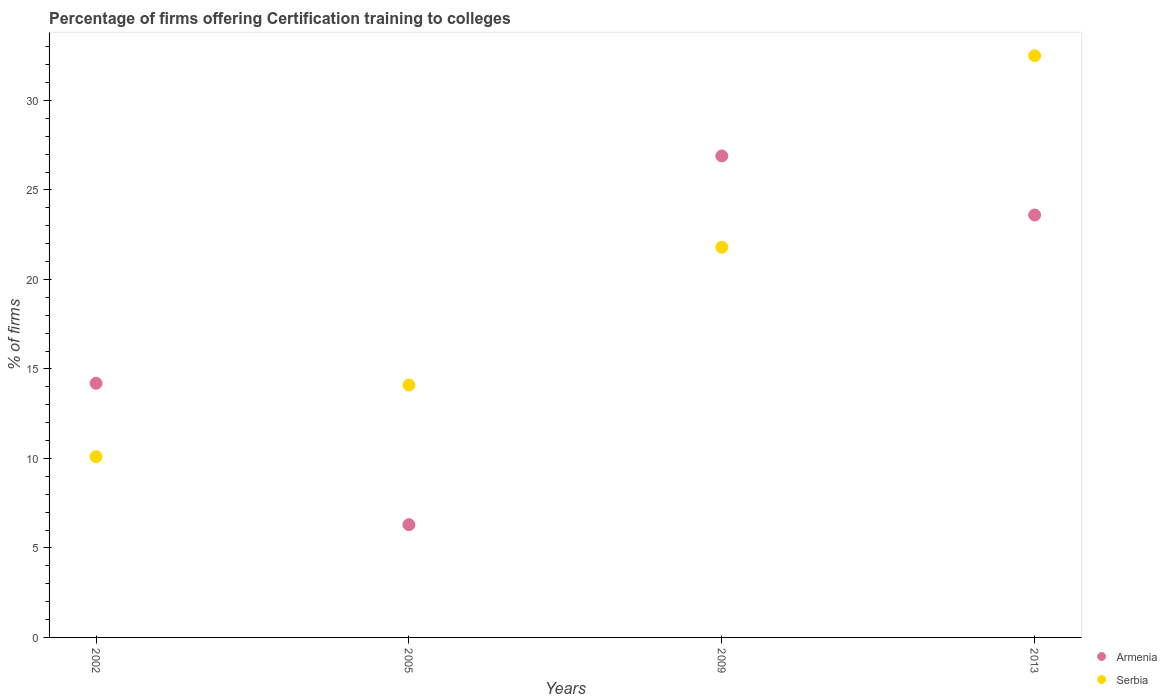How many different coloured dotlines are there?
Give a very brief answer. 2. Is the number of dotlines equal to the number of legend labels?
Your answer should be very brief. Yes. What is the percentage of firms offering certification training to colleges in Serbia in 2013?
Provide a short and direct response. 32.5. Across all years, what is the maximum percentage of firms offering certification training to colleges in Serbia?
Your answer should be very brief. 32.5. In which year was the percentage of firms offering certification training to colleges in Serbia maximum?
Give a very brief answer. 2013. What is the total percentage of firms offering certification training to colleges in Serbia in the graph?
Keep it short and to the point. 78.5. What is the difference between the percentage of firms offering certification training to colleges in Serbia in 2002 and that in 2009?
Make the answer very short. -11.7. What is the difference between the percentage of firms offering certification training to colleges in Armenia in 2002 and the percentage of firms offering certification training to colleges in Serbia in 2009?
Keep it short and to the point. -7.6. What is the average percentage of firms offering certification training to colleges in Armenia per year?
Your response must be concise. 17.75. In the year 2009, what is the difference between the percentage of firms offering certification training to colleges in Armenia and percentage of firms offering certification training to colleges in Serbia?
Ensure brevity in your answer.  5.1. In how many years, is the percentage of firms offering certification training to colleges in Armenia greater than 10 %?
Provide a succinct answer. 3. What is the ratio of the percentage of firms offering certification training to colleges in Serbia in 2002 to that in 2009?
Keep it short and to the point. 0.46. What is the difference between the highest and the second highest percentage of firms offering certification training to colleges in Armenia?
Provide a short and direct response. 3.3. What is the difference between the highest and the lowest percentage of firms offering certification training to colleges in Serbia?
Keep it short and to the point. 22.4. Is the sum of the percentage of firms offering certification training to colleges in Serbia in 2002 and 2013 greater than the maximum percentage of firms offering certification training to colleges in Armenia across all years?
Offer a very short reply. Yes. Does the percentage of firms offering certification training to colleges in Armenia monotonically increase over the years?
Give a very brief answer. No. Is the percentage of firms offering certification training to colleges in Armenia strictly less than the percentage of firms offering certification training to colleges in Serbia over the years?
Provide a short and direct response. No. How many dotlines are there?
Offer a terse response. 2. Are the values on the major ticks of Y-axis written in scientific E-notation?
Offer a terse response. No. Does the graph contain any zero values?
Offer a terse response. No. Does the graph contain grids?
Offer a very short reply. No. Where does the legend appear in the graph?
Provide a succinct answer. Bottom right. How many legend labels are there?
Your answer should be very brief. 2. How are the legend labels stacked?
Your response must be concise. Vertical. What is the title of the graph?
Ensure brevity in your answer.  Percentage of firms offering Certification training to colleges. What is the label or title of the Y-axis?
Your answer should be compact. % of firms. What is the % of firms of Armenia in 2002?
Make the answer very short. 14.2. What is the % of firms of Armenia in 2009?
Your answer should be very brief. 26.9. What is the % of firms in Serbia in 2009?
Ensure brevity in your answer.  21.8. What is the % of firms of Armenia in 2013?
Offer a very short reply. 23.6. What is the % of firms in Serbia in 2013?
Ensure brevity in your answer.  32.5. Across all years, what is the maximum % of firms in Armenia?
Ensure brevity in your answer.  26.9. Across all years, what is the maximum % of firms in Serbia?
Your answer should be very brief. 32.5. Across all years, what is the minimum % of firms in Serbia?
Offer a terse response. 10.1. What is the total % of firms in Armenia in the graph?
Offer a very short reply. 71. What is the total % of firms of Serbia in the graph?
Offer a terse response. 78.5. What is the difference between the % of firms of Serbia in 2002 and that in 2005?
Keep it short and to the point. -4. What is the difference between the % of firms of Serbia in 2002 and that in 2009?
Provide a succinct answer. -11.7. What is the difference between the % of firms in Serbia in 2002 and that in 2013?
Make the answer very short. -22.4. What is the difference between the % of firms of Armenia in 2005 and that in 2009?
Make the answer very short. -20.6. What is the difference between the % of firms of Serbia in 2005 and that in 2009?
Your answer should be compact. -7.7. What is the difference between the % of firms in Armenia in 2005 and that in 2013?
Your response must be concise. -17.3. What is the difference between the % of firms in Serbia in 2005 and that in 2013?
Provide a short and direct response. -18.4. What is the difference between the % of firms of Armenia in 2009 and that in 2013?
Provide a short and direct response. 3.3. What is the difference between the % of firms in Serbia in 2009 and that in 2013?
Offer a terse response. -10.7. What is the difference between the % of firms in Armenia in 2002 and the % of firms in Serbia in 2013?
Provide a succinct answer. -18.3. What is the difference between the % of firms of Armenia in 2005 and the % of firms of Serbia in 2009?
Provide a succinct answer. -15.5. What is the difference between the % of firms in Armenia in 2005 and the % of firms in Serbia in 2013?
Provide a succinct answer. -26.2. What is the difference between the % of firms of Armenia in 2009 and the % of firms of Serbia in 2013?
Your response must be concise. -5.6. What is the average % of firms of Armenia per year?
Provide a short and direct response. 17.75. What is the average % of firms in Serbia per year?
Make the answer very short. 19.62. In the year 2013, what is the difference between the % of firms of Armenia and % of firms of Serbia?
Provide a succinct answer. -8.9. What is the ratio of the % of firms of Armenia in 2002 to that in 2005?
Your answer should be compact. 2.25. What is the ratio of the % of firms of Serbia in 2002 to that in 2005?
Offer a terse response. 0.72. What is the ratio of the % of firms in Armenia in 2002 to that in 2009?
Your answer should be very brief. 0.53. What is the ratio of the % of firms of Serbia in 2002 to that in 2009?
Provide a short and direct response. 0.46. What is the ratio of the % of firms of Armenia in 2002 to that in 2013?
Keep it short and to the point. 0.6. What is the ratio of the % of firms of Serbia in 2002 to that in 2013?
Your answer should be very brief. 0.31. What is the ratio of the % of firms of Armenia in 2005 to that in 2009?
Keep it short and to the point. 0.23. What is the ratio of the % of firms of Serbia in 2005 to that in 2009?
Give a very brief answer. 0.65. What is the ratio of the % of firms in Armenia in 2005 to that in 2013?
Offer a very short reply. 0.27. What is the ratio of the % of firms of Serbia in 2005 to that in 2013?
Ensure brevity in your answer.  0.43. What is the ratio of the % of firms in Armenia in 2009 to that in 2013?
Your answer should be very brief. 1.14. What is the ratio of the % of firms in Serbia in 2009 to that in 2013?
Give a very brief answer. 0.67. What is the difference between the highest and the lowest % of firms of Armenia?
Your response must be concise. 20.6. What is the difference between the highest and the lowest % of firms of Serbia?
Ensure brevity in your answer.  22.4. 